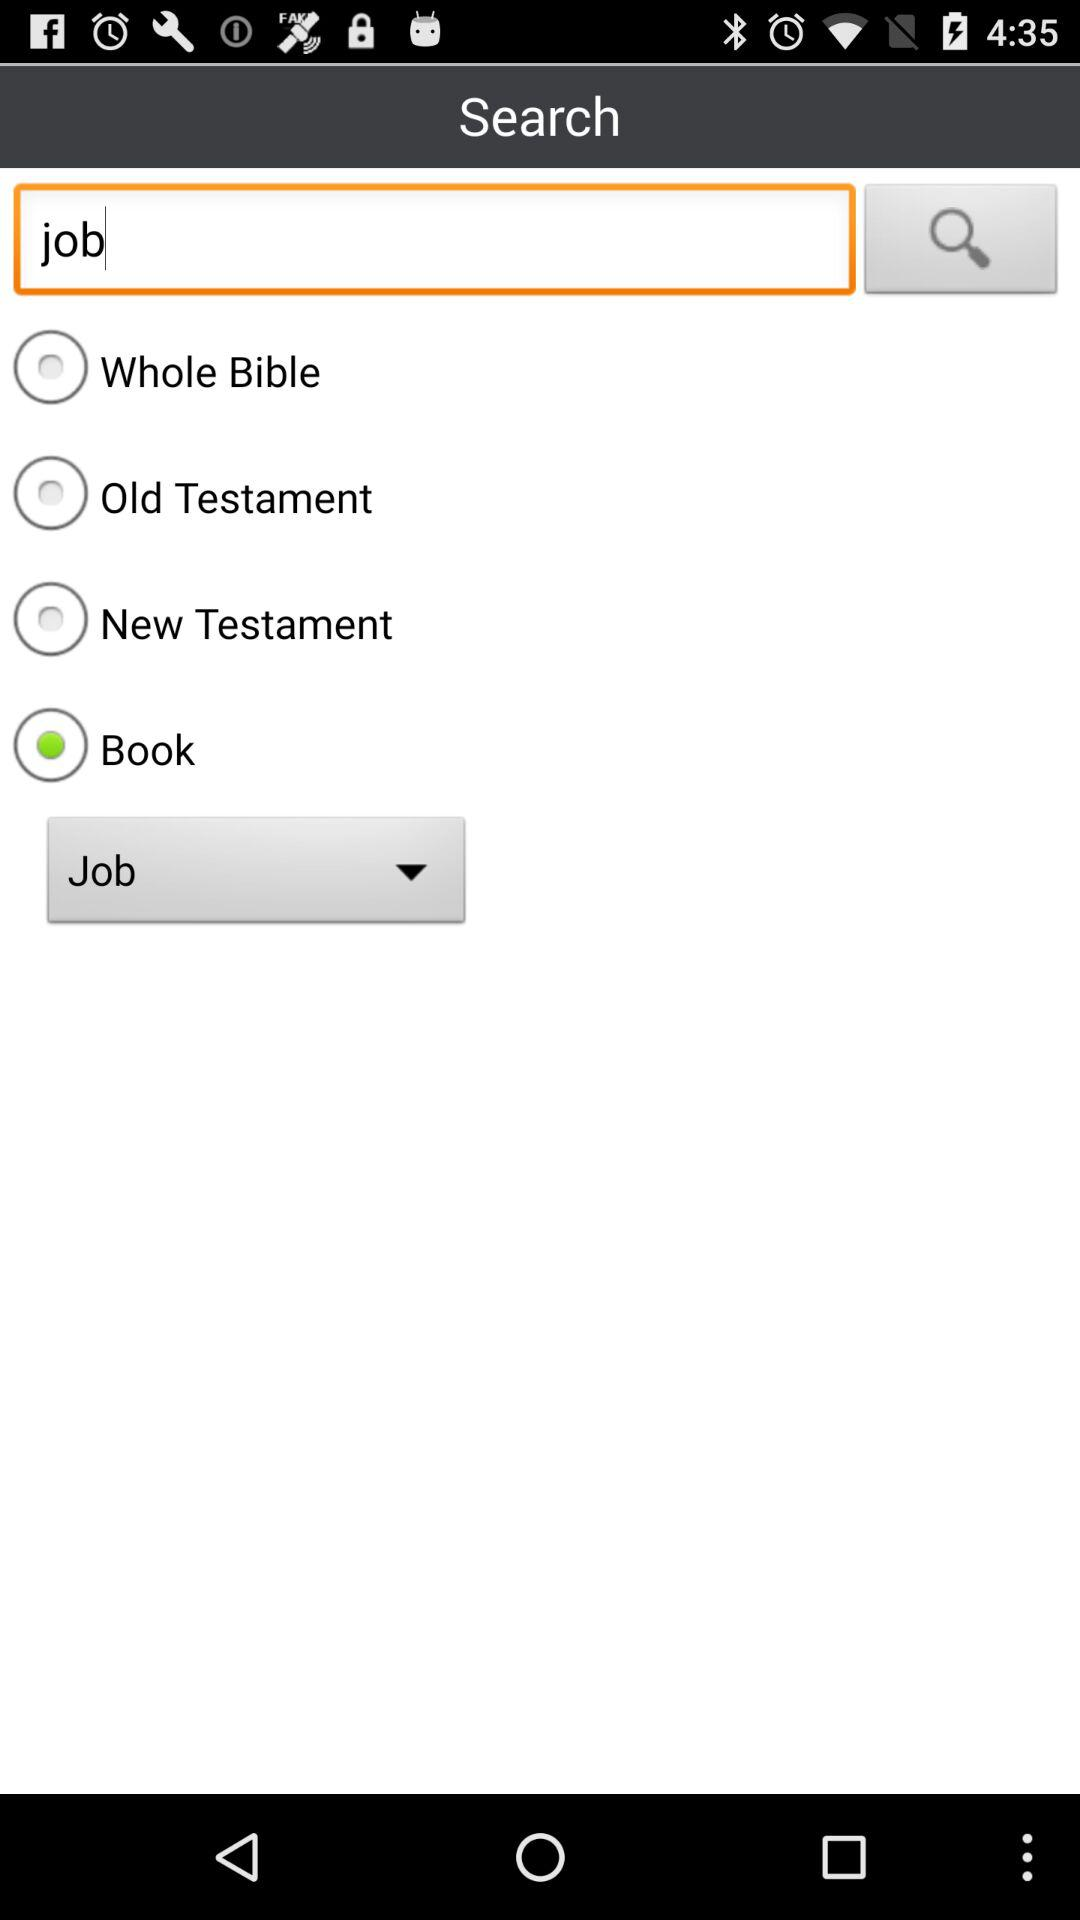What radio button is selected? The selected radio button is "Book". 